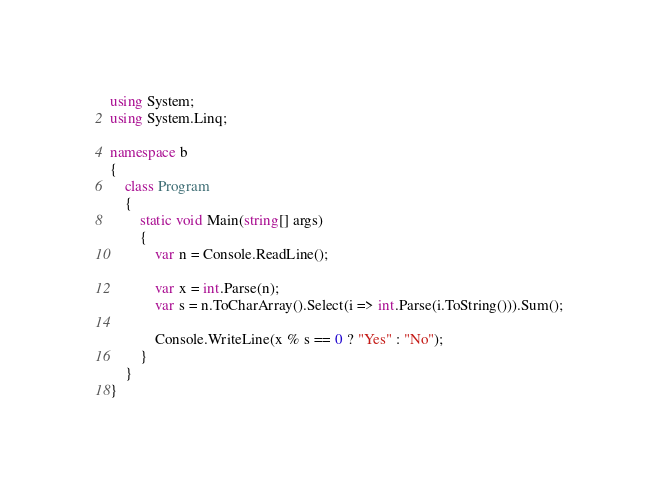<code> <loc_0><loc_0><loc_500><loc_500><_C#_>using System;
using System.Linq;

namespace b
{
    class Program
    {
        static void Main(string[] args)
        {
            var n = Console.ReadLine();

            var x = int.Parse(n);
            var s = n.ToCharArray().Select(i => int.Parse(i.ToString())).Sum();

            Console.WriteLine(x % s == 0 ? "Yes" : "No");
        }
    }
}
</code> 